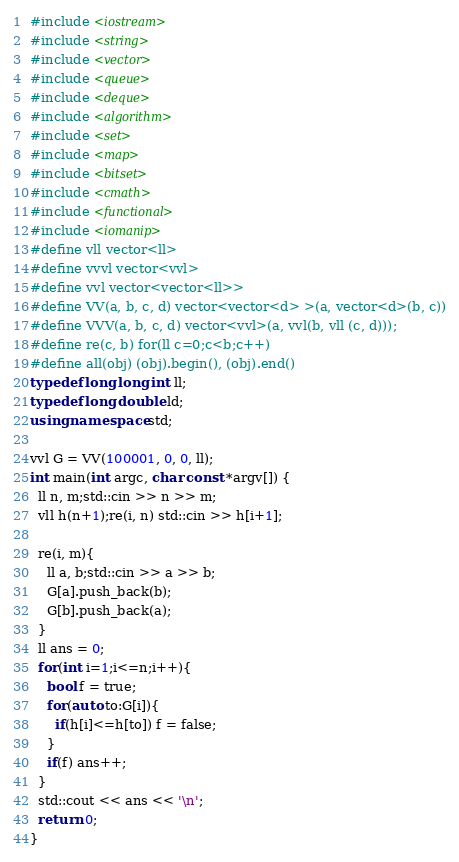Convert code to text. <code><loc_0><loc_0><loc_500><loc_500><_C++_>#include <iostream>
#include <string>
#include <vector>
#include <queue>
#include <deque>
#include <algorithm>
#include <set>
#include <map>
#include <bitset>
#include <cmath>
#include <functional>
#include <iomanip>
#define vll vector<ll>
#define vvvl vector<vvl>
#define vvl vector<vector<ll>>
#define VV(a, b, c, d) vector<vector<d> >(a, vector<d>(b, c))
#define VVV(a, b, c, d) vector<vvl>(a, vvl(b, vll (c, d)));
#define re(c, b) for(ll c=0;c<b;c++)
#define all(obj) (obj).begin(), (obj).end()
typedef long long int ll;
typedef long double ld;
using namespace std;

vvl G = VV(100001, 0, 0, ll);
int main(int argc, char const *argv[]) {
  ll n, m;std::cin >> n >> m;
  vll h(n+1);re(i, n) std::cin >> h[i+1];

  re(i, m){
    ll a, b;std::cin >> a >> b;
    G[a].push_back(b);
    G[b].push_back(a);
  }
  ll ans = 0;
  for(int i=1;i<=n;i++){
    bool f = true;
    for(auto to:G[i]){
      if(h[i]<=h[to]) f = false;
    }
    if(f) ans++;
  }
  std::cout << ans << '\n';
  return 0;
}
</code> 